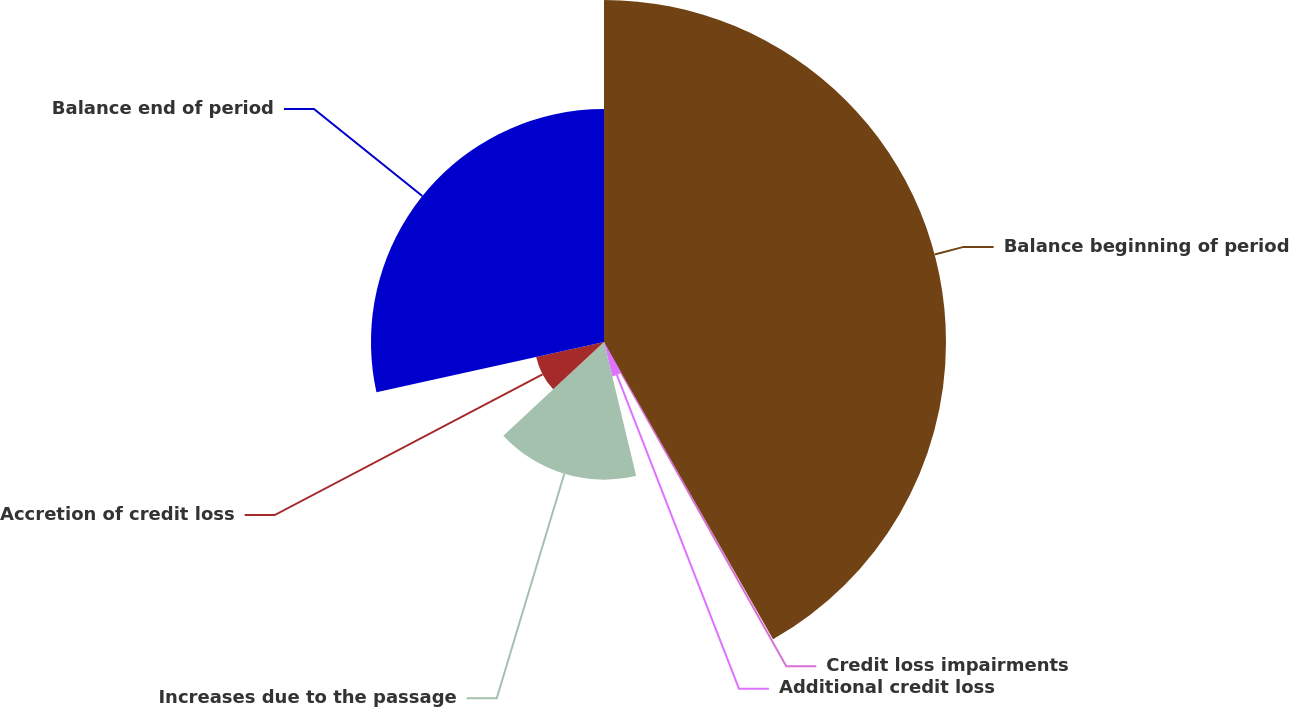Convert chart. <chart><loc_0><loc_0><loc_500><loc_500><pie_chart><fcel>Balance beginning of period<fcel>Credit loss impairments<fcel>Additional credit loss<fcel>Increases due to the passage<fcel>Accretion of credit loss<fcel>Balance end of period<nl><fcel>41.77%<fcel>0.16%<fcel>4.32%<fcel>16.81%<fcel>8.48%<fcel>28.46%<nl></chart> 